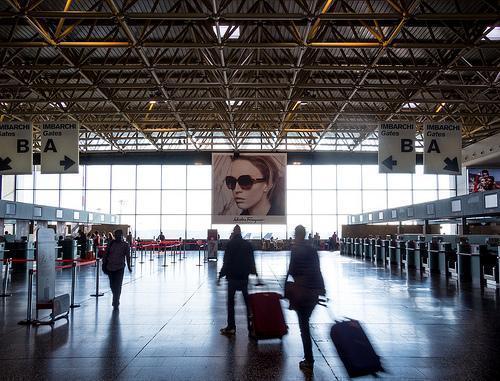How many signs are hanging?
Give a very brief answer. 5. 